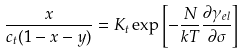Convert formula to latex. <formula><loc_0><loc_0><loc_500><loc_500>\frac { x } { c _ { t } ( 1 - x - y ) } = K _ { t } \exp \left [ - \frac { N } { k T } \frac { \partial \gamma _ { e l } } { \partial \sigma } \right ]</formula> 